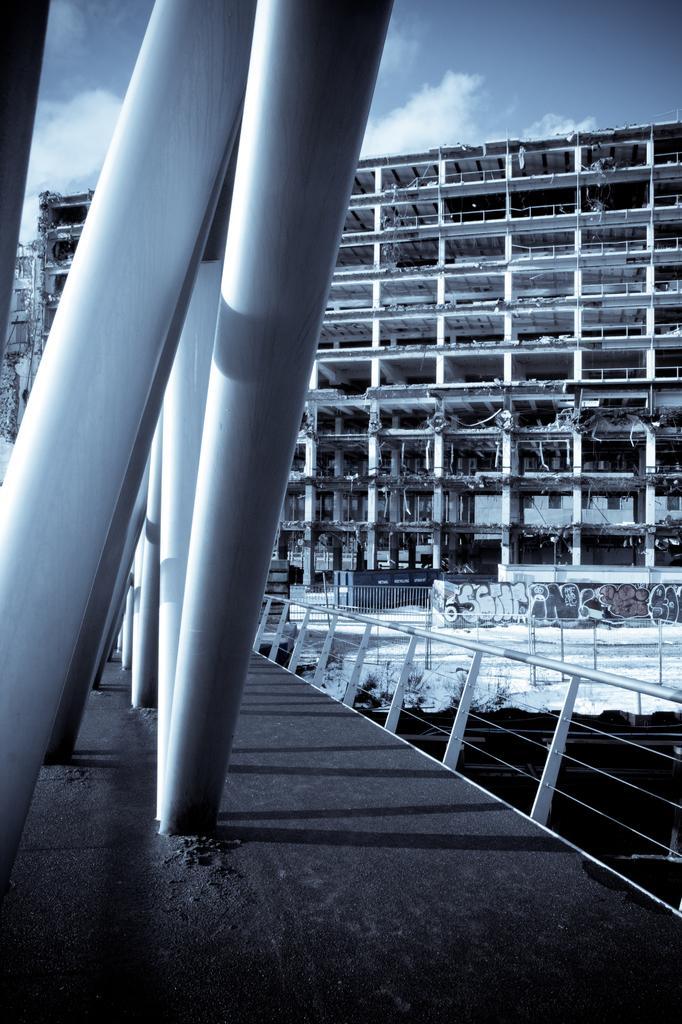Can you describe this image briefly? In this picture at the bottom it looks like a bridge, in the background I can see a building. At the top there is the sky. 